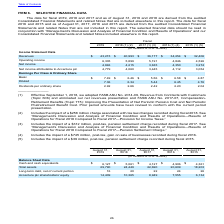According to Accenture Plc's financial document, Between 2015 to 2019, which year did Accenture earn the highest revenue? According to the financial document, 2019. The relevant text states: "2019 2018 (1) (2) 2017 (1) (3) 2016 (1) (4) 2015 (1) (5)..." Also, What is the financial impact of the post-tax, pension settlement charge recorded during fiscal 2015？ According to the financial document, $39 million. The relevant text states: "(5) Includes the impact of a $39 million, post-tax, pension settlement charge recorded during fiscal 2015...." Also, What is the company's net income attributable to Accenture plc in 2017? According to the financial document, 3,445 (in millions). The relevant text states: "income attributable to Accenture plc 4,779 4,060 3,445 4,112 3,054..." Also, What is the post-tax, gain on sale of businesses recorded during fiscal 2016? According to the financial document, 745 (in millions). The relevant text states: "(4) Includes the impact of a $745 million, post-tax, gain on sale of businesses recorded during fiscal 2016...." Also, can you calculate: What is the average revenue from 2015 to t2019? To answer this question, I need to perform calculations using the financial data. The calculation is: (43,215 +40,993+36,177+34,254+32,406)/5 , which equals 37409 (in millions). This is based on the information: "Revenues $ 43,215 $ 40,993 $ 36,177 $ 34,254 $ 32,406 Revenues $ 43,215 $ 40,993 $ 36,177 $ 34,254 $ 32,406 Revenues $ 43,215 $ 40,993 $ 36,177 $ 34,254 $ 32,406 Revenues $ 43,215 $ 40,993 $ 36,177 $ ..." The key data points involved are: 32,406, 34,254, 36,177. Also, can you calculate: What is the total dividends per ordinary share in 2018 and 2019?  Based on the calculation: $2.92 + $2.66 , the result is 5.58. This is based on the information: "Dividends per ordinary share 2.92 2.66 2.42 2.20 2.04 Dividends per ordinary share 2.92 2.66 2.42 2.20 2.04..." The key data points involved are: 2.66, 2.92. 